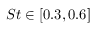<formula> <loc_0><loc_0><loc_500><loc_500>S t \in [ 0 . 3 , 0 . 6 ]</formula> 